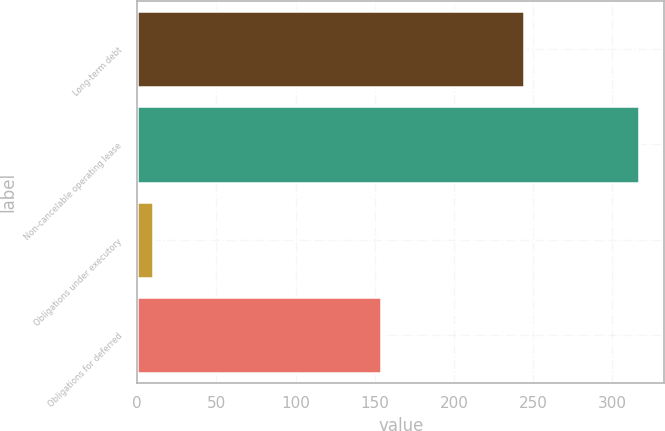Convert chart. <chart><loc_0><loc_0><loc_500><loc_500><bar_chart><fcel>Long-term debt<fcel>Non-cancelable operating lease<fcel>Obligations under executory<fcel>Obligations for deferred<nl><fcel>244.5<fcel>317<fcel>10<fcel>154.2<nl></chart> 